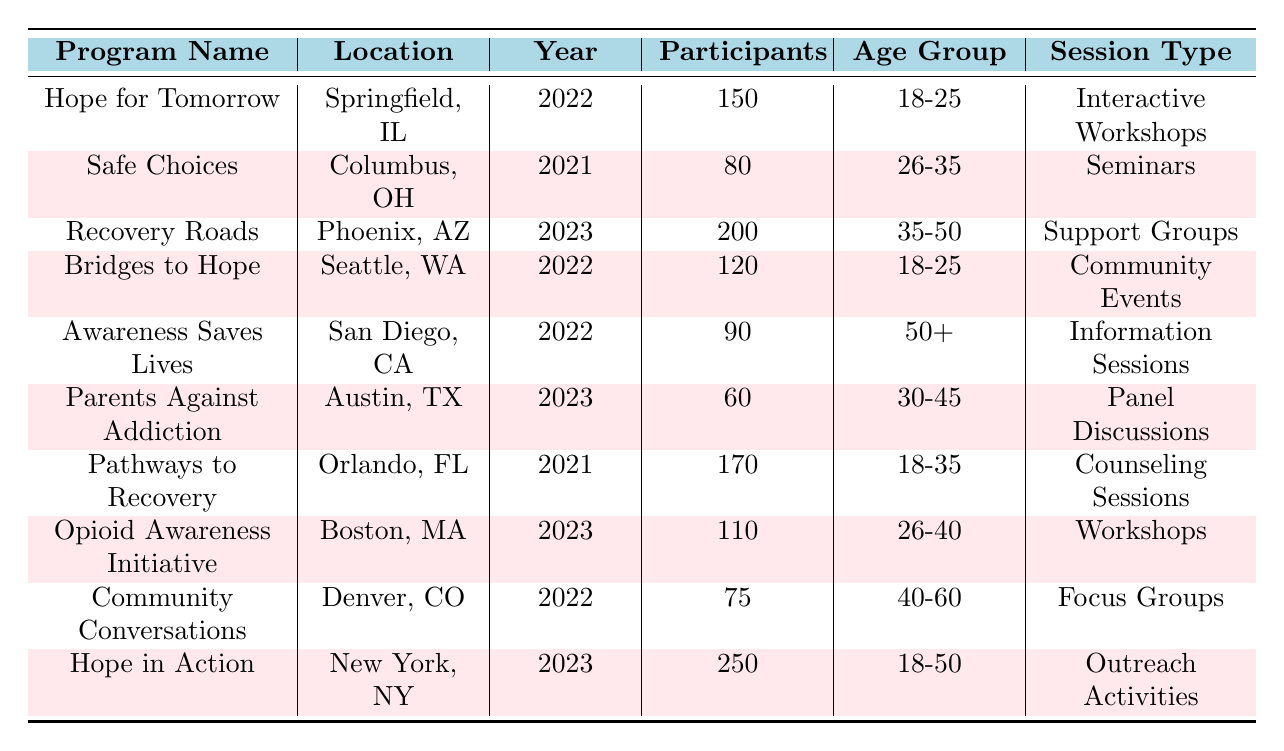What is the total number of participants in the "Hope in Action" program? The table shows that "Hope in Action" program has 250 participants listed in the participants column.
Answer: 250 Which program has the highest number of participants? The highest number of participants is found in "Hope in Action" with 250 participants.
Answer: Hope in Action How many participants were there in outreach programs focused on individuals aged 18-25? The programs aimed at the 18-25 age group are "Hope for Tomorrow" (150) and "Bridges to Hope" (120), so I sum these: 150 + 120 = 270.
Answer: 270 What percentage of participants in the "Recovery Roads" program are aged between 35-50? The "Recovery Roads" program has 200 participants, and all of them fall under the 35-50 age group, so the percentage is 200/200 = 100%.
Answer: 100% Is there a program in 2022 that had more than 100 participants? From the table, "Hope for Tomorrow" (150) and "Bridges to Hope" (120) are the programs from 2022 with more than 100 participants.
Answer: Yes What is the average number of participants across programs for the age group 18-35? The programs for the 18-35 age group are "Hope for Tomorrow" (150), "Pathways to Recovery" (170), and "Bridges to Hope" (120). Their total is 150 + 170 + 120 = 440. The average is 440 divided by 3 (the number of programs) = 146.67.
Answer: 146.67 How many programs were held in 2023? The programs identified for 2023 are "Recovery Roads," "Parents Against Addiction," "Opioid Awareness Initiative," and "Hope in Action," which totals to 4 programs.
Answer: 4 Which program located in California had the least number of participants? "Awareness Saves Lives" in San Diego, CA has 90 participants, which is the lowest compared to other programs in California.
Answer: Awareness Saves Lives What is the difference in participants between the program with the most participants and the program with the least participants? "Hope in Action" has 250 participants and the least participants is in "Parents Against Addiction" with 60. The difference is 250 - 60 = 190.
Answer: 190 How many programs had participants from the age group 40-60? There is one program that caters to the age group 40-60 called "Community Conversations," which had 75 participants.
Answer: 1 Which session type had the highest participation overall? "Hope in Action" held outreach activities with the highest participation (250). None other session type has more participants than this.
Answer: Outreach Activities 